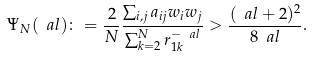<formula> <loc_0><loc_0><loc_500><loc_500>\Psi _ { N } ( \ a l ) \colon = \frac { 2 } { N } \frac { \sum _ { i , j } a _ { i j } w _ { i } w _ { j } } { \sum _ { k = 2 } ^ { N } r _ { 1 k } ^ { - \ a l } } > \frac { ( \ a l + 2 ) ^ { 2 } } { 8 \ a l } .</formula> 